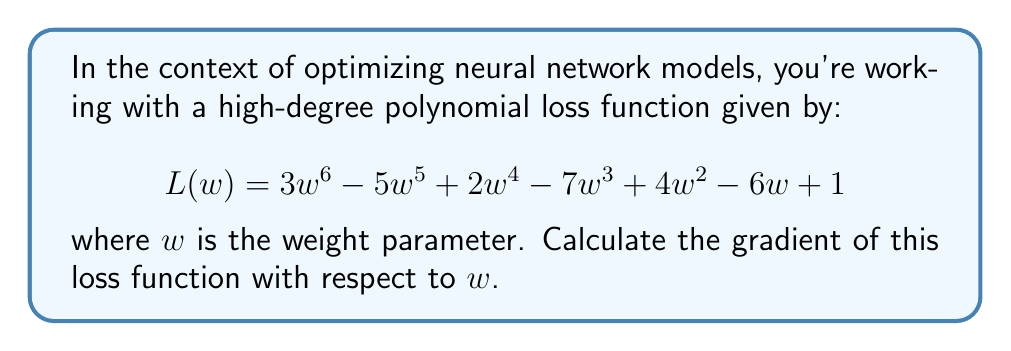Solve this math problem. To calculate the gradient of the loss function, we need to find its derivative with respect to $w$. Let's break this down step-by-step:

1) The general rule for differentiating a polynomial term $ax^n$ is:
   $$\frac{d}{dx}(ax^n) = nax^{n-1}$$

2) We'll apply this rule to each term of our polynomial:

   - For $3w^6$: $\frac{d}{dw}(3w^6) = 18w^5$
   - For $-5w^5$: $\frac{d}{dw}(-5w^5) = -25w^4$
   - For $2w^4$: $\frac{d}{dw}(2w^4) = 8w^3$
   - For $-7w^3$: $\frac{d}{dw}(-7w^3) = -21w^2$
   - For $4w^2$: $\frac{d}{dw}(4w^2) = 8w$
   - For $-6w$: $\frac{d}{dw}(-6w) = -6$
   - For the constant 1: $\frac{d}{dw}(1) = 0$

3) Now, we sum all these terms to get the final gradient:

   $$\frac{dL}{dw} = 18w^5 - 25w^4 + 8w^3 - 21w^2 + 8w - 6$$

This gradient function represents the slope of the loss function at any given point $w$. In the context of neural network optimization, this gradient would be used in gradient descent algorithms to update the weight parameter $w$ and minimize the loss function.
Answer: $$\frac{dL}{dw} = 18w^5 - 25w^4 + 8w^3 - 21w^2 + 8w - 6$$ 